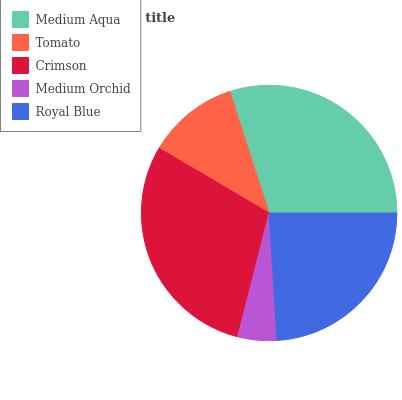Is Medium Orchid the minimum?
Answer yes or no. Yes. Is Medium Aqua the maximum?
Answer yes or no. Yes. Is Tomato the minimum?
Answer yes or no. No. Is Tomato the maximum?
Answer yes or no. No. Is Medium Aqua greater than Tomato?
Answer yes or no. Yes. Is Tomato less than Medium Aqua?
Answer yes or no. Yes. Is Tomato greater than Medium Aqua?
Answer yes or no. No. Is Medium Aqua less than Tomato?
Answer yes or no. No. Is Royal Blue the high median?
Answer yes or no. Yes. Is Royal Blue the low median?
Answer yes or no. Yes. Is Medium Orchid the high median?
Answer yes or no. No. Is Medium Aqua the low median?
Answer yes or no. No. 